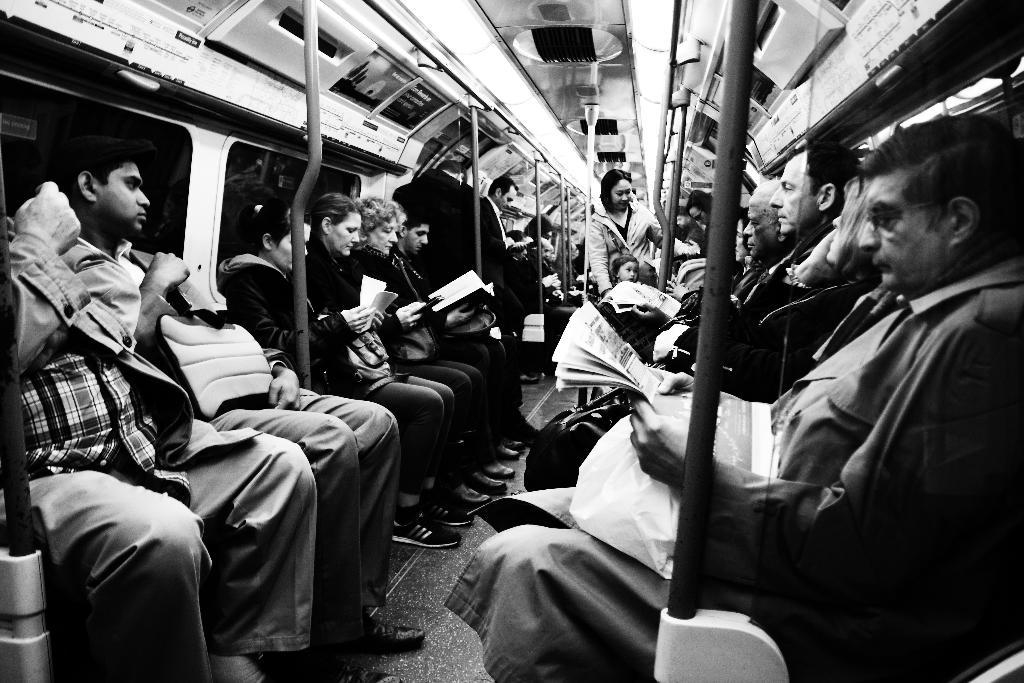What are the people sitting on in the image? The fact does not specify what the people are sitting on, but there are many people sitting on an object. What are the people holding in their hands? The people are holding objects in their hands. What can be seen in the image besides the people sitting and standing? There are many poles in the image. How many people are standing in the image? There are few people standing in the image. Can you see any fangs or wounds on the people in the image? There is no mention of fangs or wounds in the image, so we cannot see any. Are there any socks visible on the people in the image? The fact does not mention socks, so we cannot determine if any are visible. 